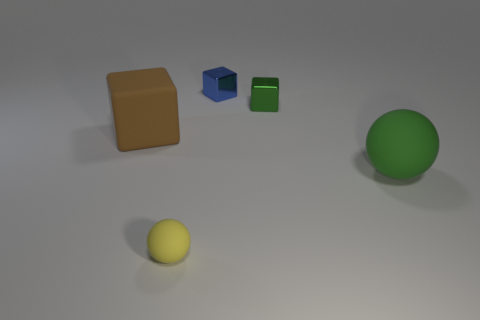Add 3 brown matte things. How many objects exist? 8 Subtract all cubes. How many objects are left? 2 Subtract all tiny yellow matte objects. Subtract all tiny blue rubber cylinders. How many objects are left? 4 Add 5 small shiny objects. How many small shiny objects are left? 7 Add 1 tiny green shiny cubes. How many tiny green shiny cubes exist? 2 Subtract 0 blue spheres. How many objects are left? 5 